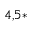Convert formula to latex. <formula><loc_0><loc_0><loc_500><loc_500>^ { 4 , 5 \ast }</formula> 